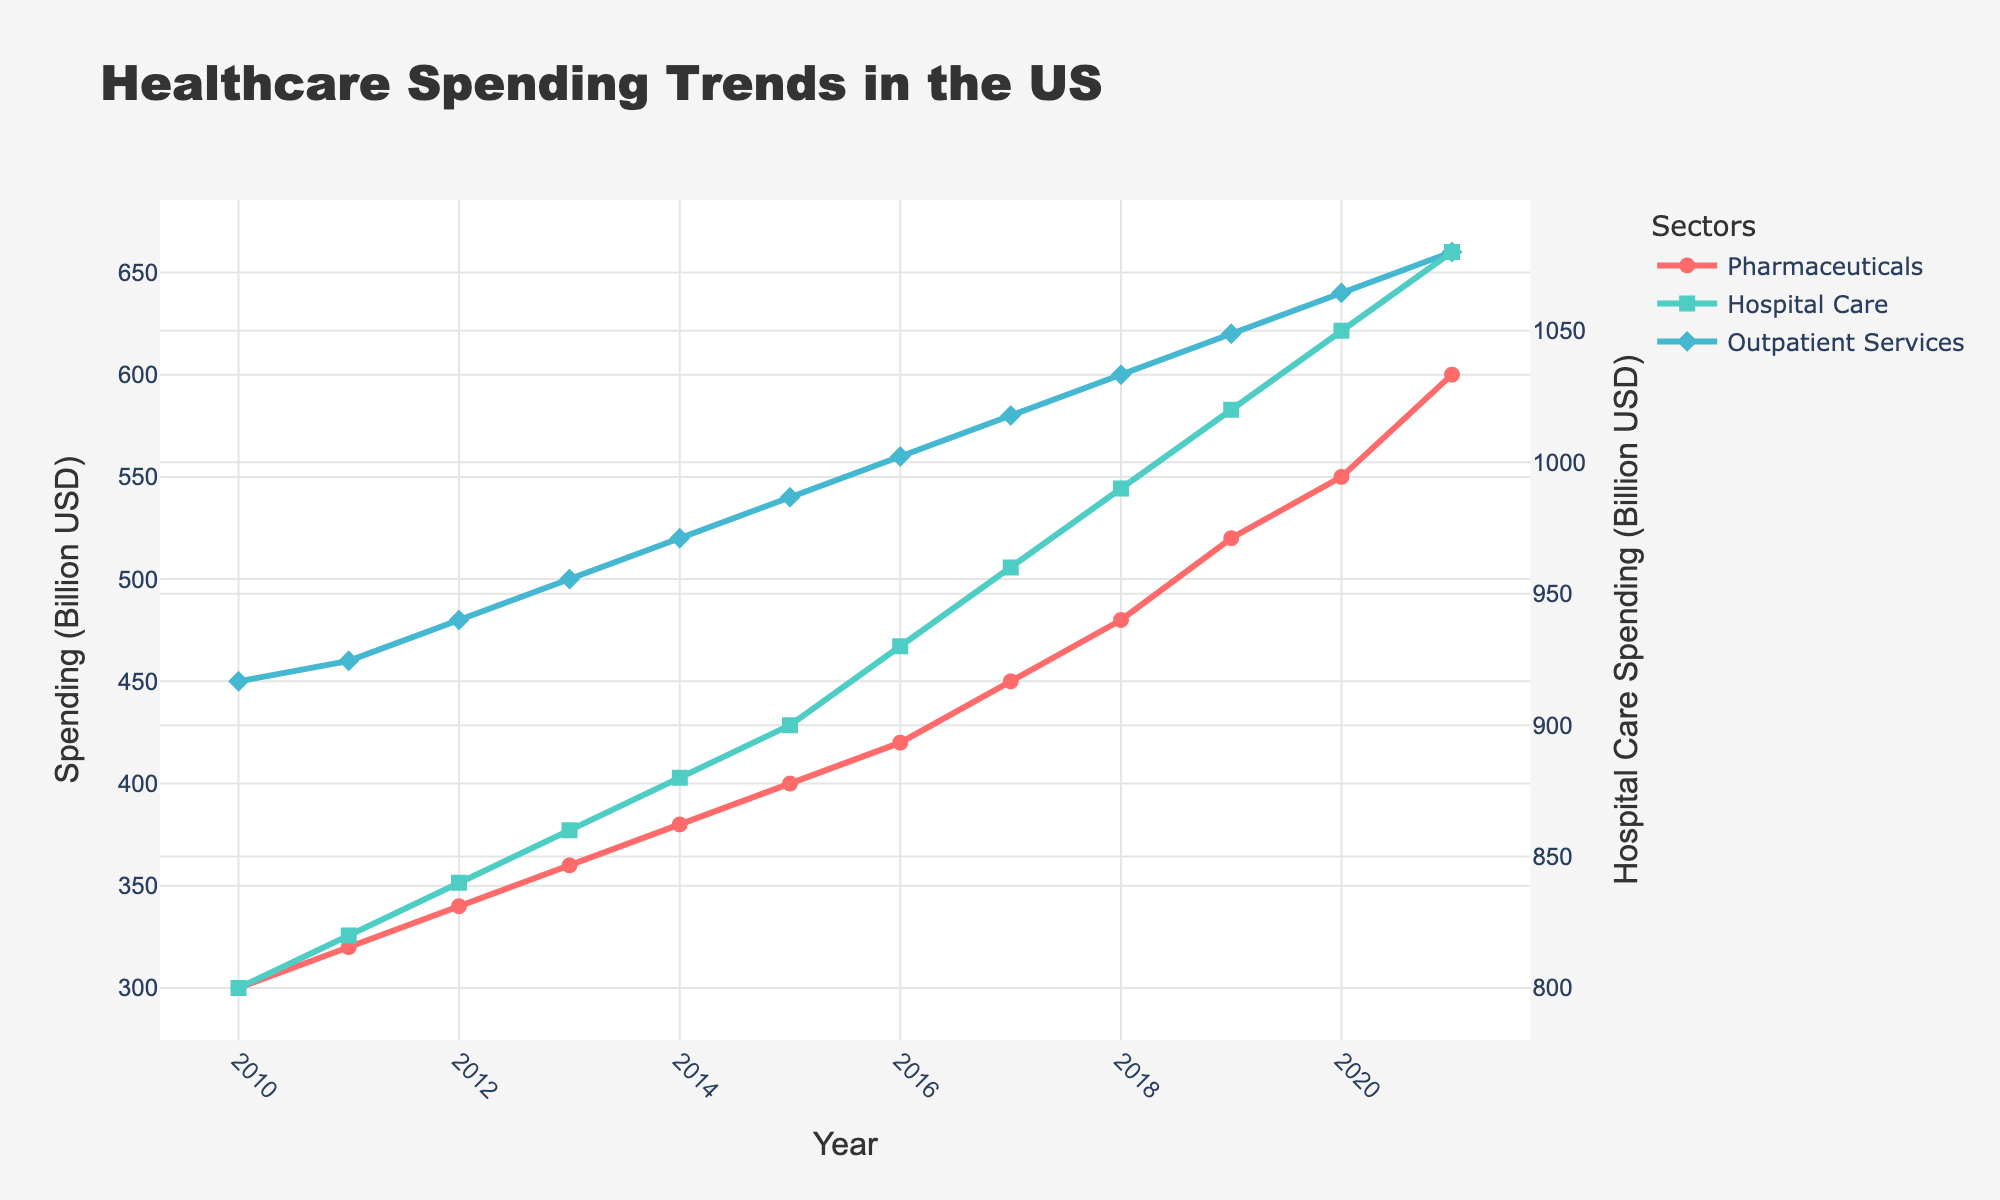What is the title of the plot? The title of the plot is displayed at the top center of the figure and reads "Healthcare Spending Trends in the US."
Answer: Healthcare Spending Trends in the US What are the sectors represented in the plot? The plot contains lines representing three sectors: Pharmaceuticals, Hospital Care, and Outpatient Services. These are labeled directly on the plot and indicated in the legend.
Answer: Pharmaceuticals, Hospital Care, Outpatient Services Which sector has the highest spending in 2021? By observing the y-values for the year 2021, Hospital Care shows a spending of 1080 billion USD, which is higher than the values for Pharmaceuticals (600 billion USD) and Outpatient Services (660 billion USD).
Answer: Hospital Care By how much did spending on Pharmaceuticals increase from 2010 to 2021? The y-values for Pharmaceuticals in 2010 and 2021 are 300 and 600 billion USD, respectively. The increase is 600 - 300 = 300 billion USD.
Answer: 300 billion USD What is the total spending on Outpatient Services over the years presented? By summing the y-values for Outpatient Services from 2010 to 2021, the total spending is 450 + 460 + 480 + 500 + 520 + 540 + 560 + 580 + 600 + 620 + 640 + 660 = 7110 billion USD.
Answer: 7110 billion USD How does the trend in Hospital Care spending compare to Pharmaceuticals between 2010 and 2021? Hospital Care spending increases steadily from 2010 to 2021, and so does Pharmaceuticals spending. However, Hospital Care starts at a much higher value (800 vs. 300 billion USD in 2010) and continues to be higher through 2021 (1080 vs. 600 billion USD).
Answer: Hospital Care increased more overall In which year did Outpatient Services spending cross 500 billion USD? Observing the plot, Outpatient Services spending reached 500 billion USD in the year 2013.
Answer: 2013 Which sector had the greatest increase in spending between 2019 and 2020? Hospital Care increased from 1020 to 1050 billion USD, by 30 billion; Pharmaceuticals increased from 520 to 550 billion USD, by 30 billion; Outpatient Services increased from 620 to 640 billion USD, by 20 billion. Hospital Care and Pharmaceuticals both saw an increase of 30 billion USD.
Answer: Hospital Care and Pharmaceuticals What was the average annual spending on Pharmaceuticals from 2010 to 2021? Sum the annual spending on Pharmaceuticals across the years and divide by the number of years: (300 + 320 + 340 + 360 + 380 + 400 + 420 + 450 + 480 + 520 + 550 + 600)/12 = 4050/12 = 337.5 billion USD.
Answer: 337.5 billion USD 